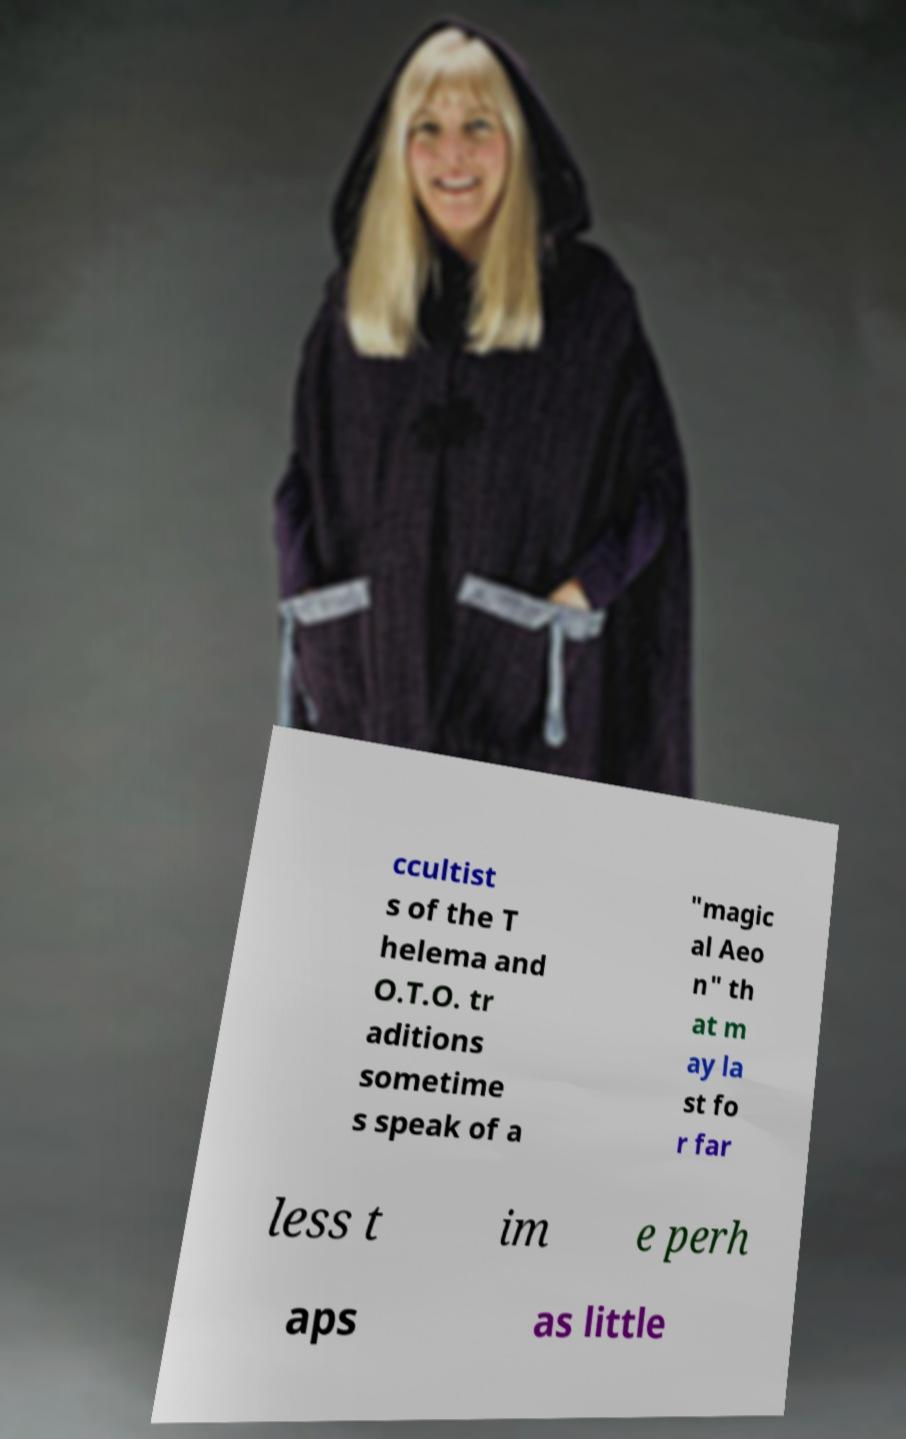Please identify and transcribe the text found in this image. ccultist s of the T helema and O.T.O. tr aditions sometime s speak of a "magic al Aeo n" th at m ay la st fo r far less t im e perh aps as little 